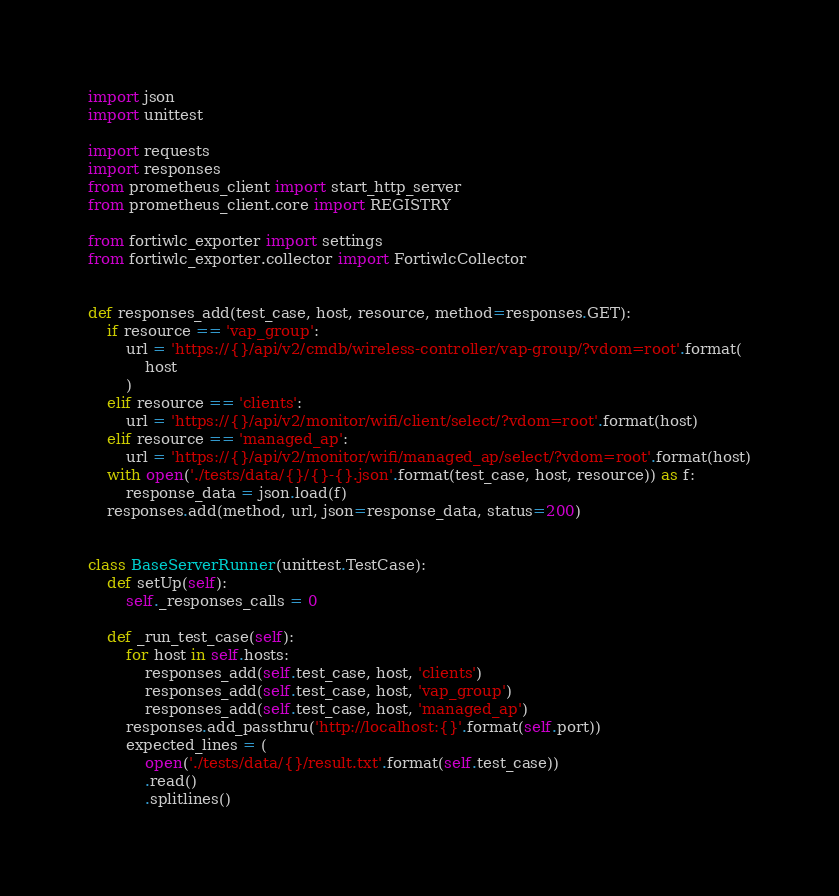<code> <loc_0><loc_0><loc_500><loc_500><_Python_>import json
import unittest

import requests
import responses
from prometheus_client import start_http_server
from prometheus_client.core import REGISTRY

from fortiwlc_exporter import settings
from fortiwlc_exporter.collector import FortiwlcCollector


def responses_add(test_case, host, resource, method=responses.GET):
    if resource == 'vap_group':
        url = 'https://{}/api/v2/cmdb/wireless-controller/vap-group/?vdom=root'.format(
            host
        )
    elif resource == 'clients':
        url = 'https://{}/api/v2/monitor/wifi/client/select/?vdom=root'.format(host)
    elif resource == 'managed_ap':
        url = 'https://{}/api/v2/monitor/wifi/managed_ap/select/?vdom=root'.format(host)
    with open('./tests/data/{}/{}-{}.json'.format(test_case, host, resource)) as f:
        response_data = json.load(f)
    responses.add(method, url, json=response_data, status=200)


class BaseServerRunner(unittest.TestCase):
    def setUp(self):
        self._responses_calls = 0

    def _run_test_case(self):
        for host in self.hosts:
            responses_add(self.test_case, host, 'clients')
            responses_add(self.test_case, host, 'vap_group')
            responses_add(self.test_case, host, 'managed_ap')
        responses.add_passthru('http://localhost:{}'.format(self.port))
        expected_lines = (
            open('./tests/data/{}/result.txt'.format(self.test_case))
            .read()
            .splitlines()</code> 